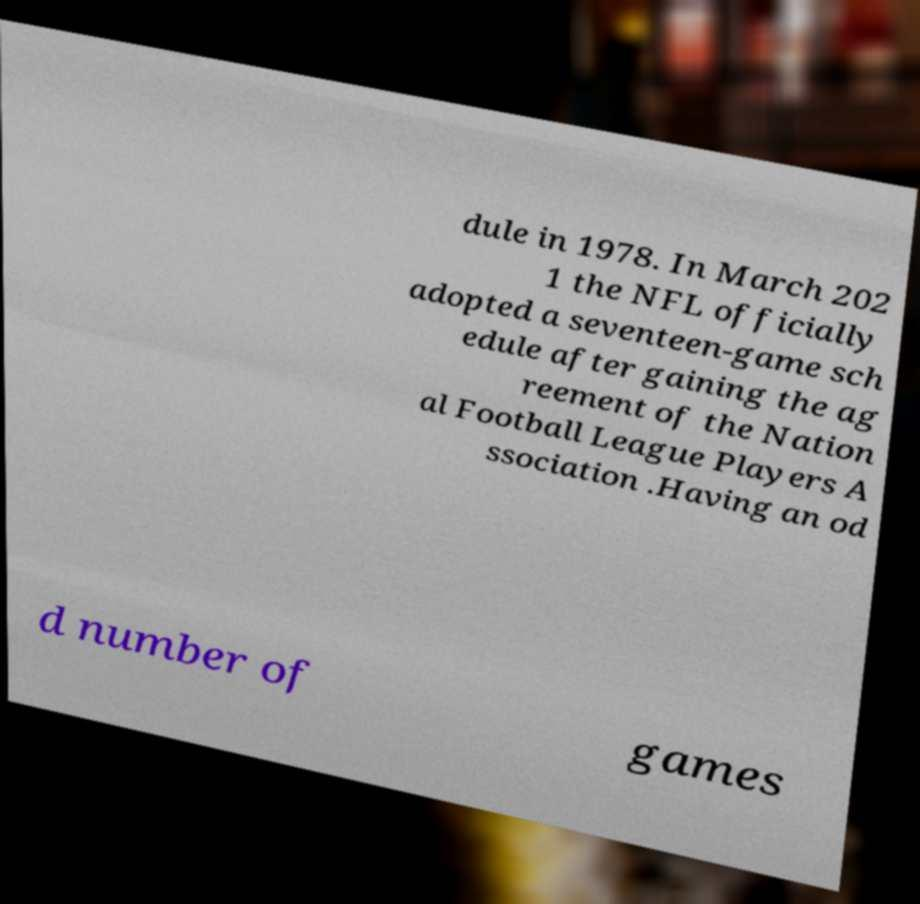Please identify and transcribe the text found in this image. dule in 1978. In March 202 1 the NFL officially adopted a seventeen-game sch edule after gaining the ag reement of the Nation al Football League Players A ssociation .Having an od d number of games 